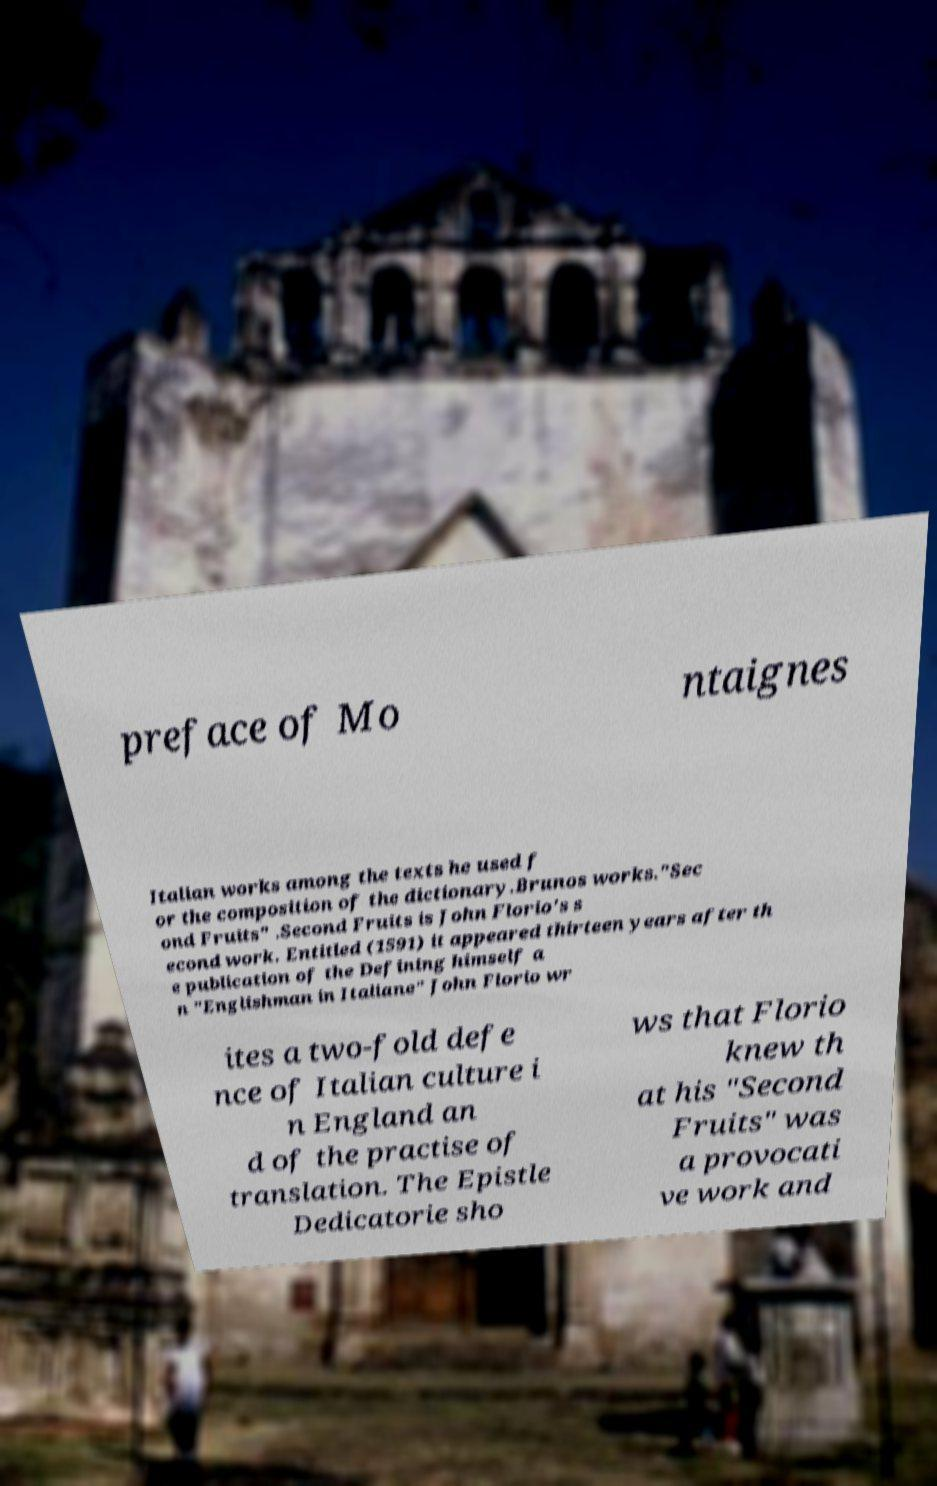Could you extract and type out the text from this image? preface of Mo ntaignes Italian works among the texts he used f or the composition of the dictionary.Brunos works."Sec ond Fruits" .Second Fruits is John Florio's s econd work. Entitled (1591) it appeared thirteen years after th e publication of the Defining himself a n "Englishman in Italiane" John Florio wr ites a two-fold defe nce of Italian culture i n England an d of the practise of translation. The Epistle Dedicatorie sho ws that Florio knew th at his "Second Fruits" was a provocati ve work and 